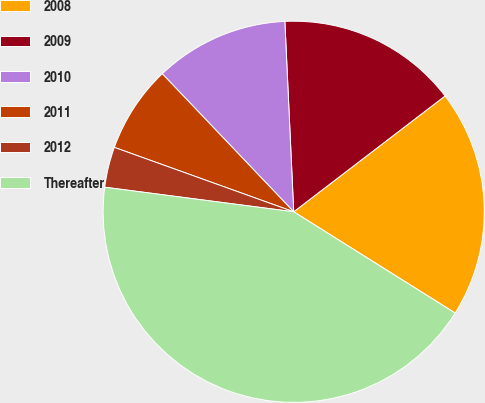Convert chart to OTSL. <chart><loc_0><loc_0><loc_500><loc_500><pie_chart><fcel>2008<fcel>2009<fcel>2010<fcel>2011<fcel>2012<fcel>Thereafter<nl><fcel>19.31%<fcel>15.34%<fcel>11.37%<fcel>7.4%<fcel>3.43%<fcel>43.13%<nl></chart> 